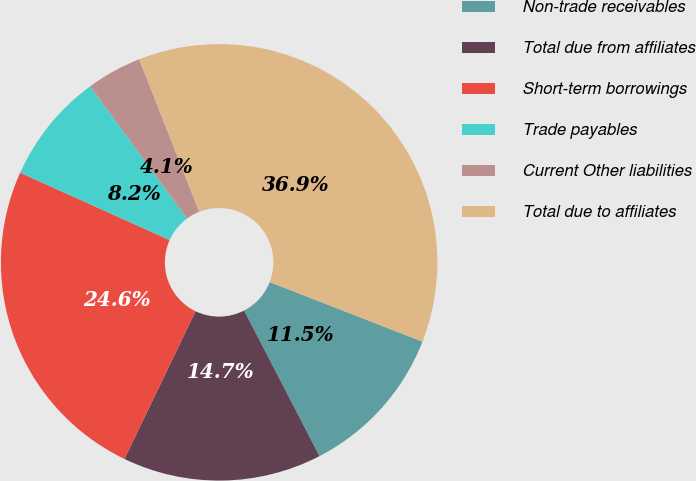<chart> <loc_0><loc_0><loc_500><loc_500><pie_chart><fcel>Non-trade receivables<fcel>Total due from affiliates<fcel>Short-term borrowings<fcel>Trade payables<fcel>Current Other liabilities<fcel>Total due to affiliates<nl><fcel>11.48%<fcel>14.75%<fcel>24.59%<fcel>8.2%<fcel>4.1%<fcel>36.89%<nl></chart> 